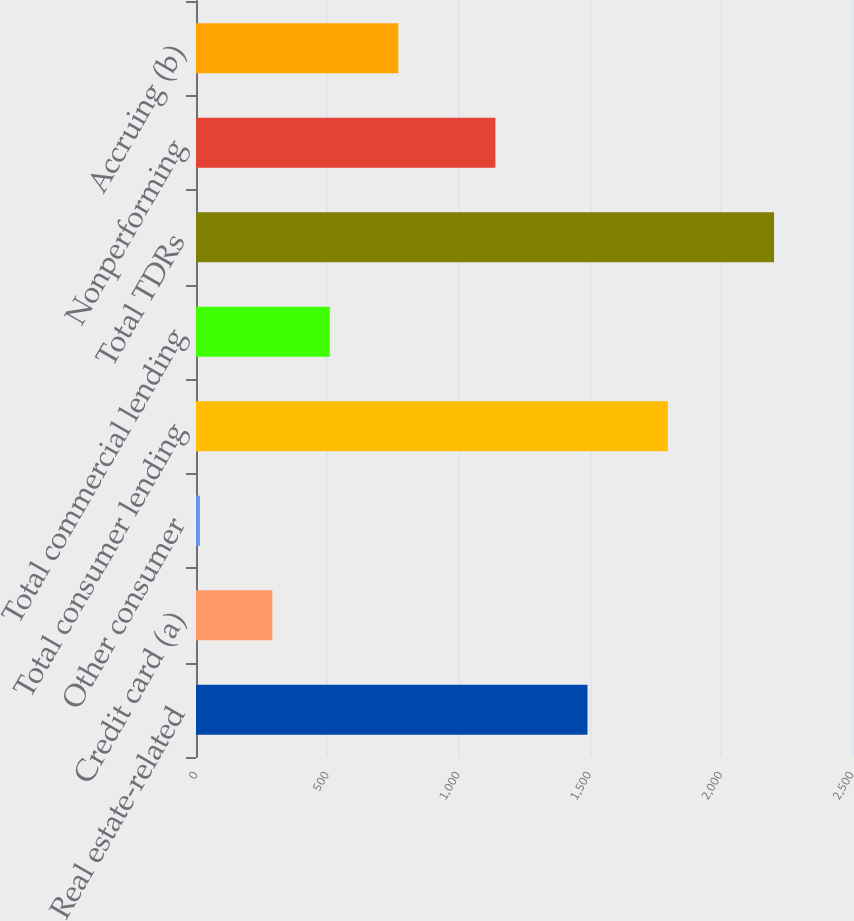<chart> <loc_0><loc_0><loc_500><loc_500><bar_chart><fcel>Real estate-related<fcel>Credit card (a)<fcel>Other consumer<fcel>Total consumer lending<fcel>Total commercial lending<fcel>Total TDRs<fcel>Nonperforming<fcel>Accruing (b)<nl><fcel>1492<fcel>291<fcel>15<fcel>1798<fcel>509.8<fcel>2203<fcel>1141<fcel>771<nl></chart> 